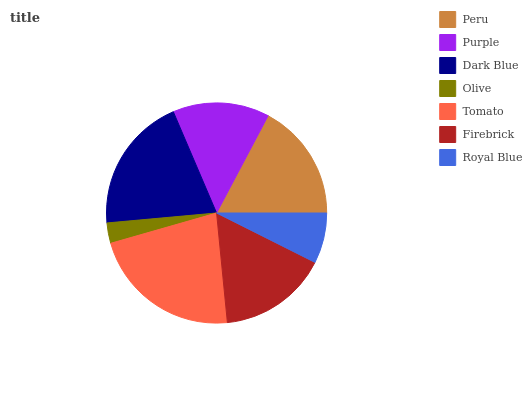Is Olive the minimum?
Answer yes or no. Yes. Is Tomato the maximum?
Answer yes or no. Yes. Is Purple the minimum?
Answer yes or no. No. Is Purple the maximum?
Answer yes or no. No. Is Peru greater than Purple?
Answer yes or no. Yes. Is Purple less than Peru?
Answer yes or no. Yes. Is Purple greater than Peru?
Answer yes or no. No. Is Peru less than Purple?
Answer yes or no. No. Is Firebrick the high median?
Answer yes or no. Yes. Is Firebrick the low median?
Answer yes or no. Yes. Is Peru the high median?
Answer yes or no. No. Is Royal Blue the low median?
Answer yes or no. No. 